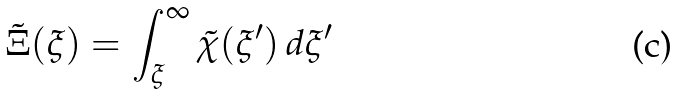<formula> <loc_0><loc_0><loc_500><loc_500>\tilde { \Xi } ( \xi ) = \int _ { \xi } ^ { \infty } \tilde { \chi } ( \xi ^ { \prime } ) \, d \xi ^ { \prime }</formula> 